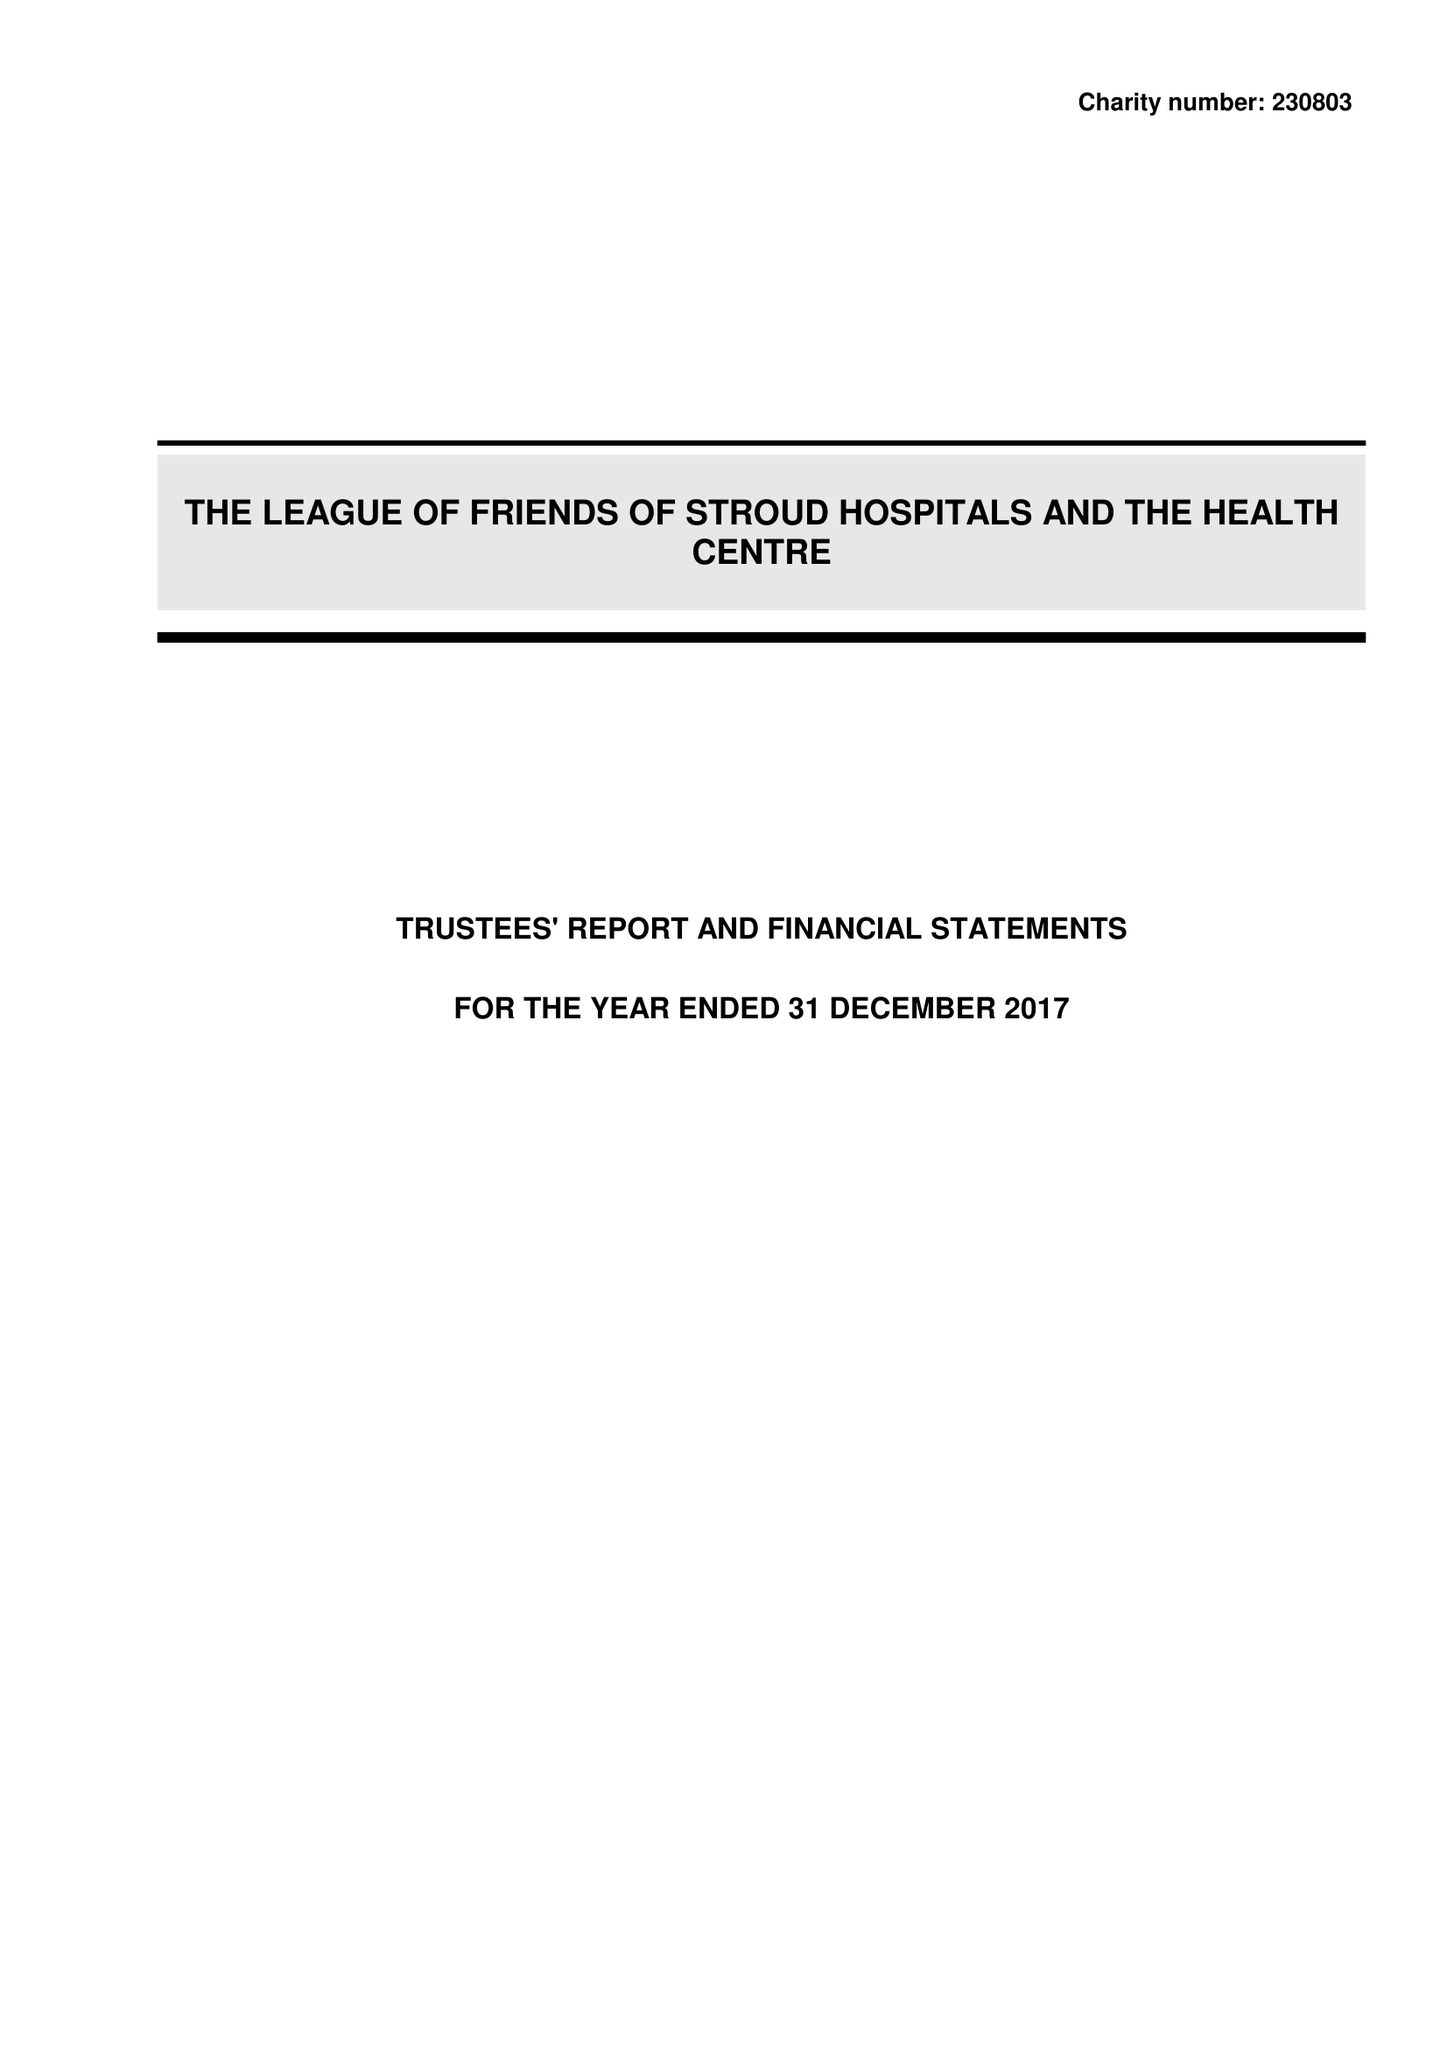What is the value for the address__postcode?
Answer the question using a single word or phrase. GL5 2HY 